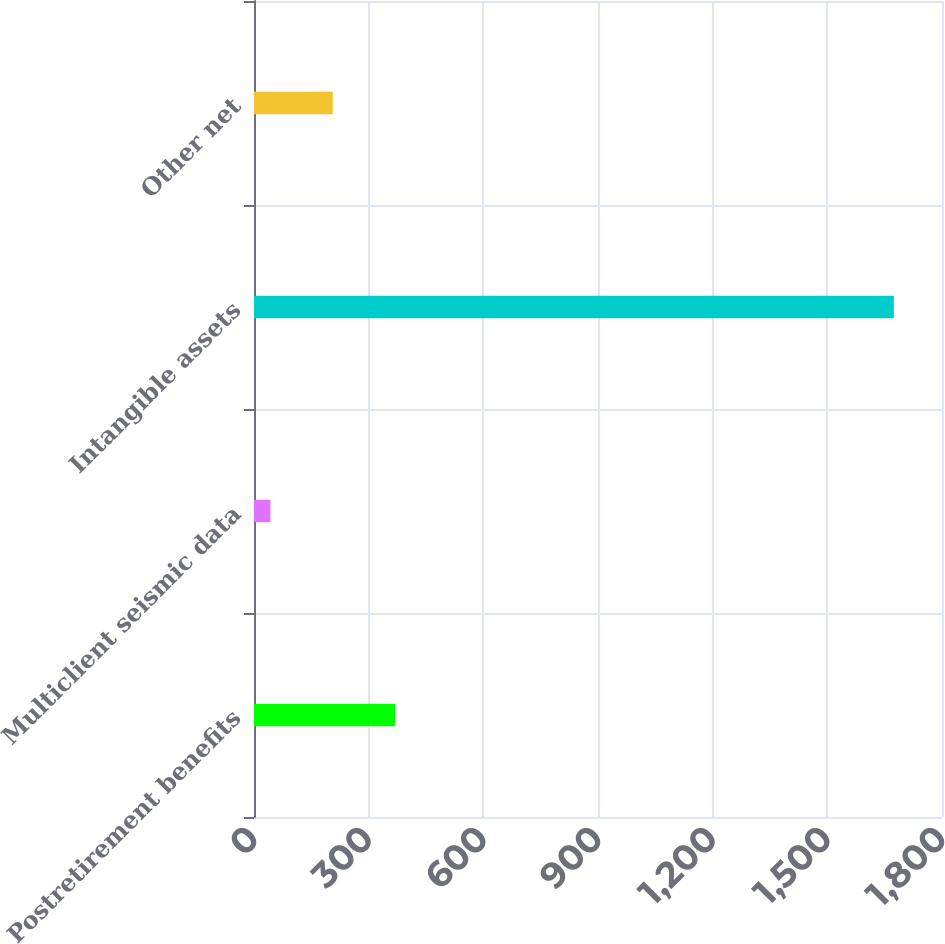<chart> <loc_0><loc_0><loc_500><loc_500><bar_chart><fcel>Postretirement benefits<fcel>Multiclient seismic data<fcel>Intangible assets<fcel>Other net<nl><fcel>369.2<fcel>43<fcel>1674<fcel>206.1<nl></chart> 